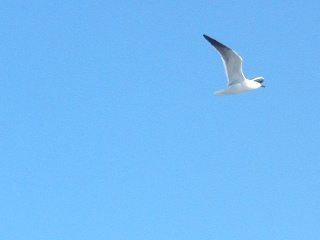This bird seems alone. Write a short story about its journey to find other birds. In a land where the sky stretched forever, a lone seagull named Zephyr soared through the endless blue. Unlike other birds, Zephyr craved adventure beyond the familiar beaches. His family and friends preferred to stay by the bustling shorelines, but Zephyr longed for the mystery of the open sky. One fateful morning, with a final glance at his nesting ground, Zephyr set off north, following an ancient migratory path known only to a few. Days turned into weeks, and Zephyr battled through fierce storms and navigated over sprawling forests and towering mountains. Along his journey, he met diverse avian families, each teaching him a new call, a new skill. One crisp dawn, his perseverance paid off. As he approached a vast, pristine lake shimmering under the morning sun, he was greeted by the harmonious calls of hundreds of birds. Zephyr had found a sanctuary where birds of all species gathered every year. Here, in this haven, he realized that his journey wasn't just about finding other birds but discovering the depths of his own spirit, forever changed by the endless horizon he had dared to explore. 